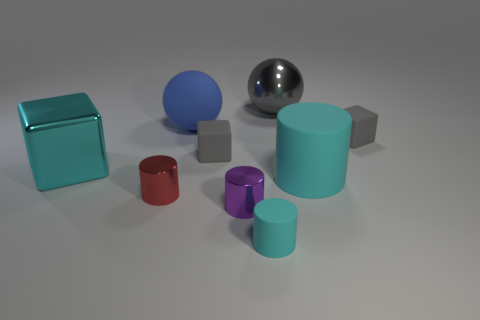Subtract all blue cubes. How many cyan cylinders are left? 2 Add 1 large metallic balls. How many objects exist? 10 Subtract all blue cylinders. Subtract all brown cubes. How many cylinders are left? 4 Subtract all cubes. How many objects are left? 6 Subtract all big cyan cylinders. Subtract all gray rubber blocks. How many objects are left? 6 Add 4 tiny objects. How many tiny objects are left? 9 Add 4 big gray shiny things. How many big gray shiny things exist? 5 Subtract 0 purple cubes. How many objects are left? 9 